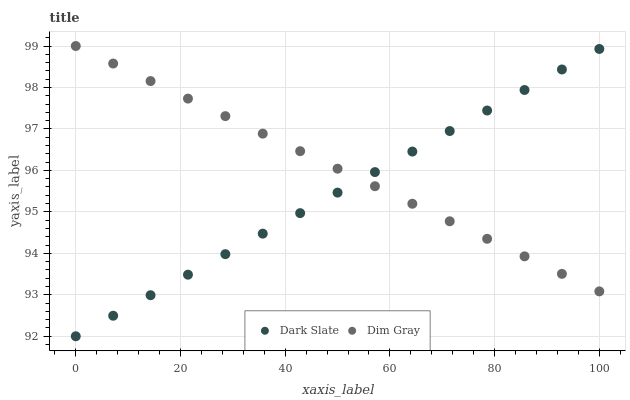Does Dark Slate have the minimum area under the curve?
Answer yes or no. Yes. Does Dim Gray have the maximum area under the curve?
Answer yes or no. Yes. Does Dim Gray have the minimum area under the curve?
Answer yes or no. No. Is Dark Slate the smoothest?
Answer yes or no. Yes. Is Dim Gray the roughest?
Answer yes or no. Yes. Is Dim Gray the smoothest?
Answer yes or no. No. Does Dark Slate have the lowest value?
Answer yes or no. Yes. Does Dim Gray have the lowest value?
Answer yes or no. No. Does Dim Gray have the highest value?
Answer yes or no. Yes. Does Dim Gray intersect Dark Slate?
Answer yes or no. Yes. Is Dim Gray less than Dark Slate?
Answer yes or no. No. Is Dim Gray greater than Dark Slate?
Answer yes or no. No. 